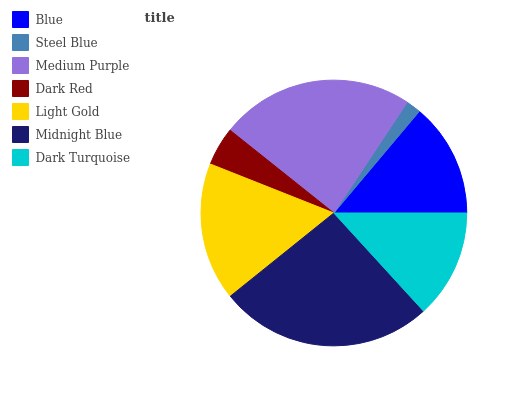Is Steel Blue the minimum?
Answer yes or no. Yes. Is Midnight Blue the maximum?
Answer yes or no. Yes. Is Medium Purple the minimum?
Answer yes or no. No. Is Medium Purple the maximum?
Answer yes or no. No. Is Medium Purple greater than Steel Blue?
Answer yes or no. Yes. Is Steel Blue less than Medium Purple?
Answer yes or no. Yes. Is Steel Blue greater than Medium Purple?
Answer yes or no. No. Is Medium Purple less than Steel Blue?
Answer yes or no. No. Is Blue the high median?
Answer yes or no. Yes. Is Blue the low median?
Answer yes or no. Yes. Is Midnight Blue the high median?
Answer yes or no. No. Is Medium Purple the low median?
Answer yes or no. No. 